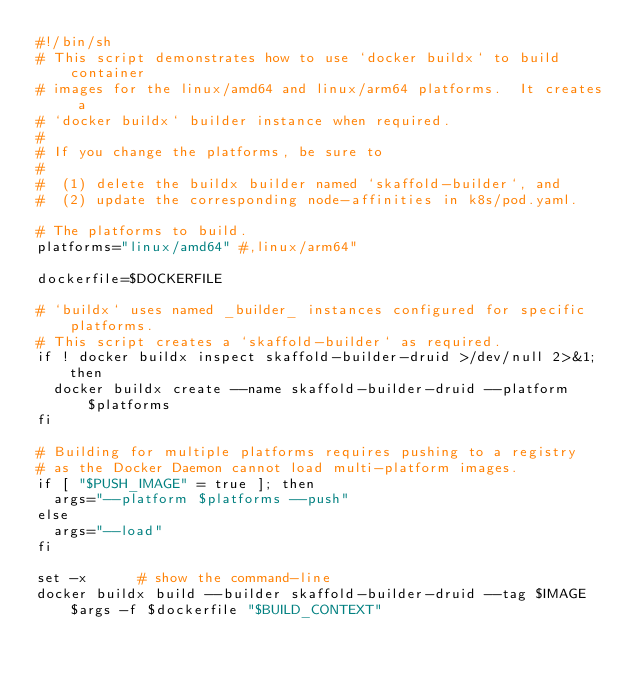<code> <loc_0><loc_0><loc_500><loc_500><_Bash_>#!/bin/sh
# This script demonstrates how to use `docker buildx` to build container
# images for the linux/amd64 and linux/arm64 platforms.  It creates a
# `docker buildx` builder instance when required.
#
# If you change the platforms, be sure to
#
#  (1) delete the buildx builder named `skaffold-builder`, and
#  (2) update the corresponding node-affinities in k8s/pod.yaml.

# The platforms to build.
platforms="linux/amd64" #,linux/arm64"

dockerfile=$DOCKERFILE

# `buildx` uses named _builder_ instances configured for specific platforms.
# This script creates a `skaffold-builder` as required.
if ! docker buildx inspect skaffold-builder-druid >/dev/null 2>&1; then
  docker buildx create --name skaffold-builder-druid --platform $platforms
fi

# Building for multiple platforms requires pushing to a registry
# as the Docker Daemon cannot load multi-platform images.
if [ "$PUSH_IMAGE" = true ]; then
  args="--platform $platforms --push"
else
  args="--load"
fi

set -x      # show the command-line
docker buildx build --builder skaffold-builder-druid --tag $IMAGE $args -f $dockerfile "$BUILD_CONTEXT"
</code> 